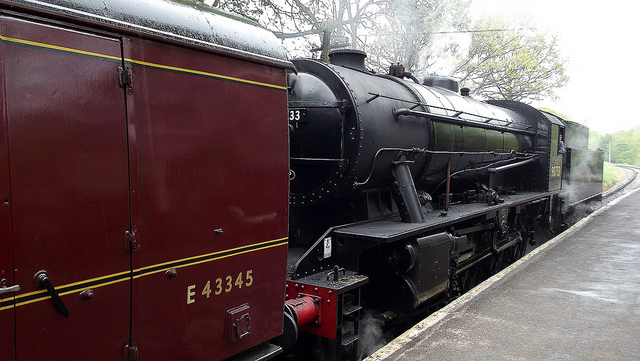Extract all visible text content from this image. 43345 E 33 